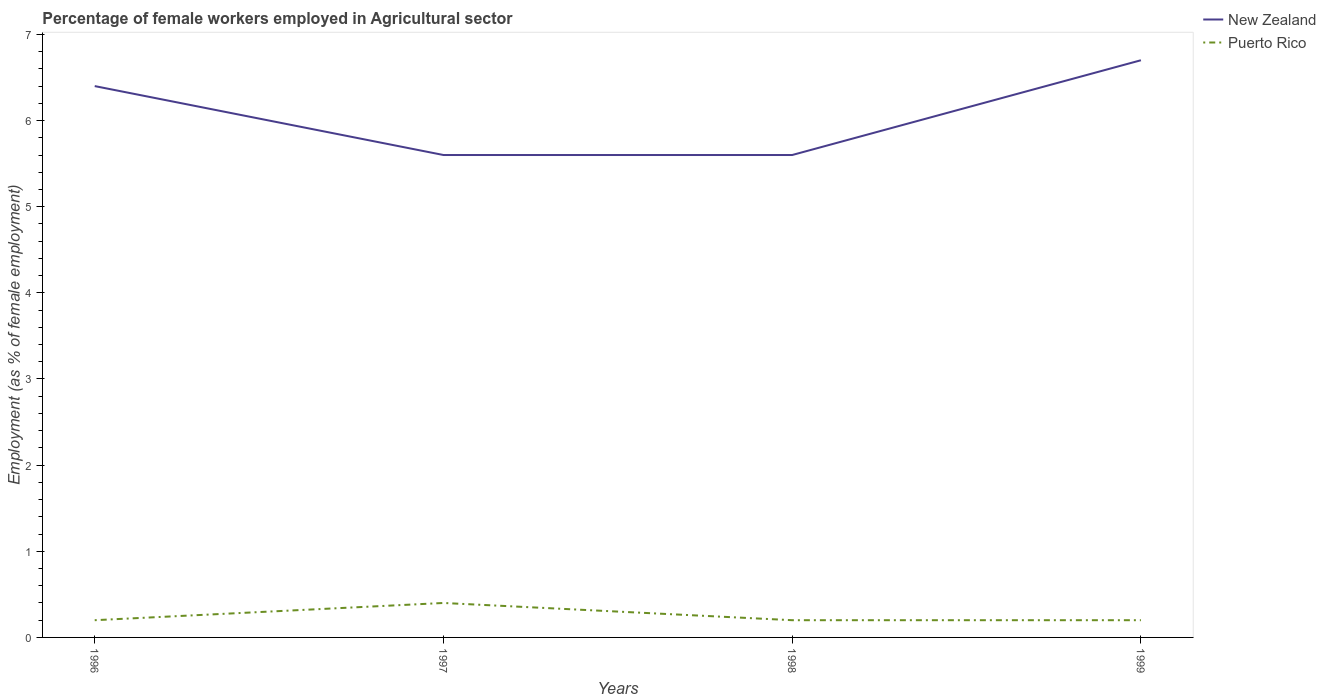How many different coloured lines are there?
Your answer should be compact. 2. Is the number of lines equal to the number of legend labels?
Keep it short and to the point. Yes. Across all years, what is the maximum percentage of females employed in Agricultural sector in New Zealand?
Your answer should be compact. 5.6. What is the difference between the highest and the second highest percentage of females employed in Agricultural sector in New Zealand?
Your answer should be compact. 1.1. What is the difference between the highest and the lowest percentage of females employed in Agricultural sector in Puerto Rico?
Make the answer very short. 1. Is the percentage of females employed in Agricultural sector in New Zealand strictly greater than the percentage of females employed in Agricultural sector in Puerto Rico over the years?
Give a very brief answer. No. How many lines are there?
Make the answer very short. 2. What is the difference between two consecutive major ticks on the Y-axis?
Make the answer very short. 1. Are the values on the major ticks of Y-axis written in scientific E-notation?
Your answer should be compact. No. Does the graph contain grids?
Give a very brief answer. No. What is the title of the graph?
Your response must be concise. Percentage of female workers employed in Agricultural sector. What is the label or title of the Y-axis?
Offer a terse response. Employment (as % of female employment). What is the Employment (as % of female employment) of New Zealand in 1996?
Your response must be concise. 6.4. What is the Employment (as % of female employment) in Puerto Rico in 1996?
Ensure brevity in your answer.  0.2. What is the Employment (as % of female employment) in New Zealand in 1997?
Provide a short and direct response. 5.6. What is the Employment (as % of female employment) in Puerto Rico in 1997?
Provide a succinct answer. 0.4. What is the Employment (as % of female employment) of New Zealand in 1998?
Ensure brevity in your answer.  5.6. What is the Employment (as % of female employment) in Puerto Rico in 1998?
Keep it short and to the point. 0.2. What is the Employment (as % of female employment) of New Zealand in 1999?
Offer a very short reply. 6.7. What is the Employment (as % of female employment) in Puerto Rico in 1999?
Make the answer very short. 0.2. Across all years, what is the maximum Employment (as % of female employment) of New Zealand?
Make the answer very short. 6.7. Across all years, what is the maximum Employment (as % of female employment) in Puerto Rico?
Your answer should be very brief. 0.4. Across all years, what is the minimum Employment (as % of female employment) in New Zealand?
Make the answer very short. 5.6. Across all years, what is the minimum Employment (as % of female employment) in Puerto Rico?
Ensure brevity in your answer.  0.2. What is the total Employment (as % of female employment) of New Zealand in the graph?
Provide a succinct answer. 24.3. What is the difference between the Employment (as % of female employment) of New Zealand in 1996 and that in 1997?
Your response must be concise. 0.8. What is the difference between the Employment (as % of female employment) in Puerto Rico in 1996 and that in 1997?
Your response must be concise. -0.2. What is the difference between the Employment (as % of female employment) of New Zealand in 1996 and that in 1998?
Keep it short and to the point. 0.8. What is the difference between the Employment (as % of female employment) of Puerto Rico in 1996 and that in 1998?
Provide a short and direct response. 0. What is the difference between the Employment (as % of female employment) in Puerto Rico in 1996 and that in 1999?
Keep it short and to the point. 0. What is the difference between the Employment (as % of female employment) in New Zealand in 1997 and that in 1999?
Your response must be concise. -1.1. What is the difference between the Employment (as % of female employment) in Puerto Rico in 1997 and that in 1999?
Your answer should be very brief. 0.2. What is the difference between the Employment (as % of female employment) of New Zealand in 1998 and that in 1999?
Provide a short and direct response. -1.1. What is the difference between the Employment (as % of female employment) in New Zealand in 1996 and the Employment (as % of female employment) in Puerto Rico in 1998?
Make the answer very short. 6.2. What is the difference between the Employment (as % of female employment) in New Zealand in 1996 and the Employment (as % of female employment) in Puerto Rico in 1999?
Keep it short and to the point. 6.2. What is the difference between the Employment (as % of female employment) in New Zealand in 1997 and the Employment (as % of female employment) in Puerto Rico in 1998?
Provide a succinct answer. 5.4. What is the difference between the Employment (as % of female employment) in New Zealand in 1997 and the Employment (as % of female employment) in Puerto Rico in 1999?
Keep it short and to the point. 5.4. What is the difference between the Employment (as % of female employment) of New Zealand in 1998 and the Employment (as % of female employment) of Puerto Rico in 1999?
Provide a short and direct response. 5.4. What is the average Employment (as % of female employment) of New Zealand per year?
Your response must be concise. 6.08. What is the average Employment (as % of female employment) in Puerto Rico per year?
Keep it short and to the point. 0.25. In the year 1997, what is the difference between the Employment (as % of female employment) in New Zealand and Employment (as % of female employment) in Puerto Rico?
Your answer should be compact. 5.2. In the year 1999, what is the difference between the Employment (as % of female employment) of New Zealand and Employment (as % of female employment) of Puerto Rico?
Provide a short and direct response. 6.5. What is the ratio of the Employment (as % of female employment) of New Zealand in 1996 to that in 1999?
Offer a very short reply. 0.96. What is the ratio of the Employment (as % of female employment) of New Zealand in 1997 to that in 1998?
Offer a very short reply. 1. What is the ratio of the Employment (as % of female employment) in Puerto Rico in 1997 to that in 1998?
Your answer should be compact. 2. What is the ratio of the Employment (as % of female employment) in New Zealand in 1997 to that in 1999?
Offer a very short reply. 0.84. What is the ratio of the Employment (as % of female employment) in New Zealand in 1998 to that in 1999?
Your answer should be compact. 0.84. What is the difference between the highest and the second highest Employment (as % of female employment) in New Zealand?
Ensure brevity in your answer.  0.3. What is the difference between the highest and the second highest Employment (as % of female employment) of Puerto Rico?
Your answer should be compact. 0.2. What is the difference between the highest and the lowest Employment (as % of female employment) in Puerto Rico?
Your response must be concise. 0.2. 